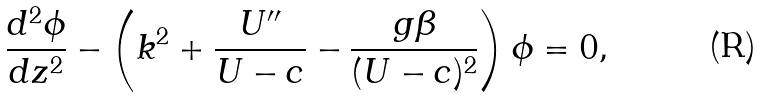Convert formula to latex. <formula><loc_0><loc_0><loc_500><loc_500>\frac { d ^ { 2 } \phi } { d z ^ { 2 } } - \left ( k ^ { 2 } + \frac { U ^ { \prime \prime } } { U - c } - \frac { g \beta } { ( U - c ) ^ { 2 } } \right ) \phi = 0 ,</formula> 